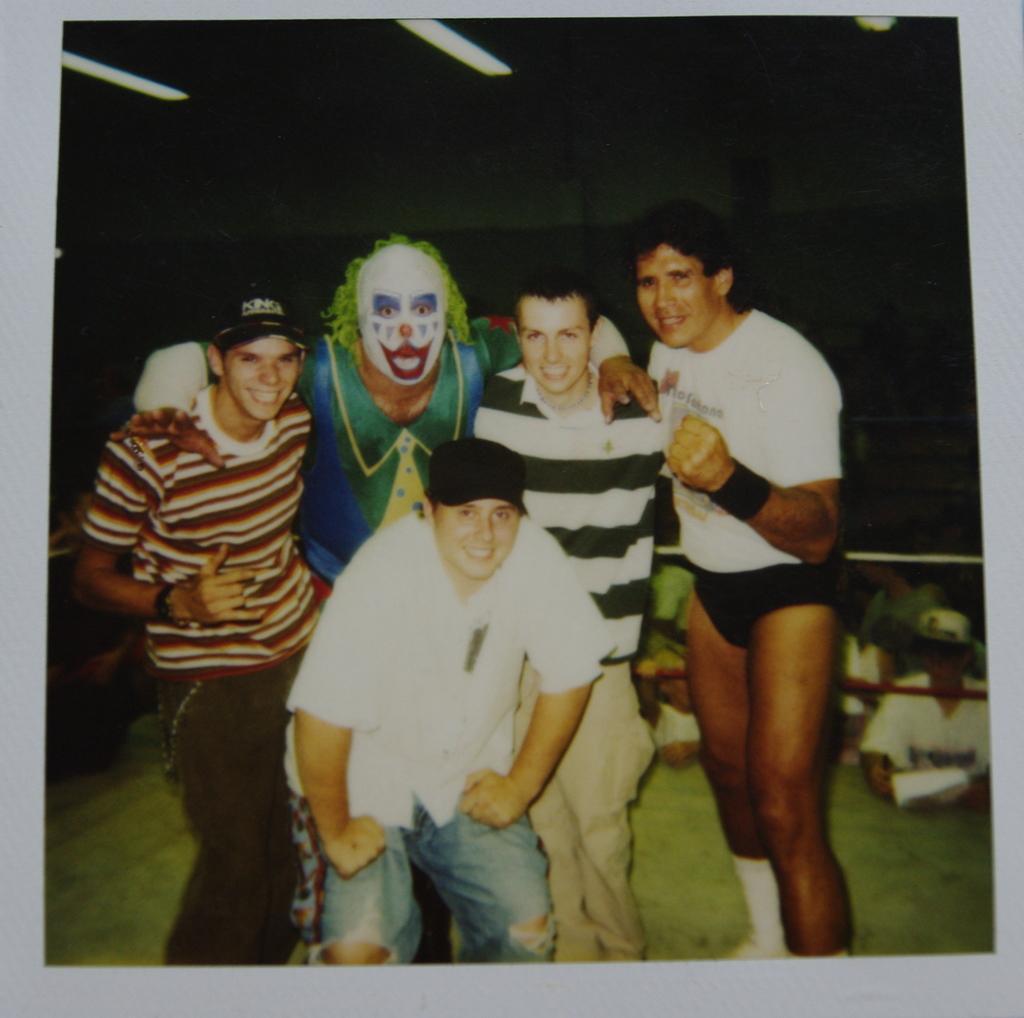How would you summarize this image in a sentence or two? In this image, we can see a poster with some people. We can also see ropes. We can see the ground and the roof. 